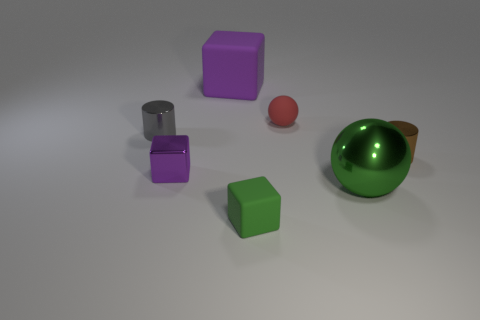Add 1 small purple things. How many objects exist? 8 Subtract all cylinders. How many objects are left? 5 Subtract all big brown cylinders. Subtract all brown cylinders. How many objects are left? 6 Add 5 tiny rubber balls. How many tiny rubber balls are left? 6 Add 3 tiny brown metallic blocks. How many tiny brown metallic blocks exist? 3 Subtract 2 purple cubes. How many objects are left? 5 